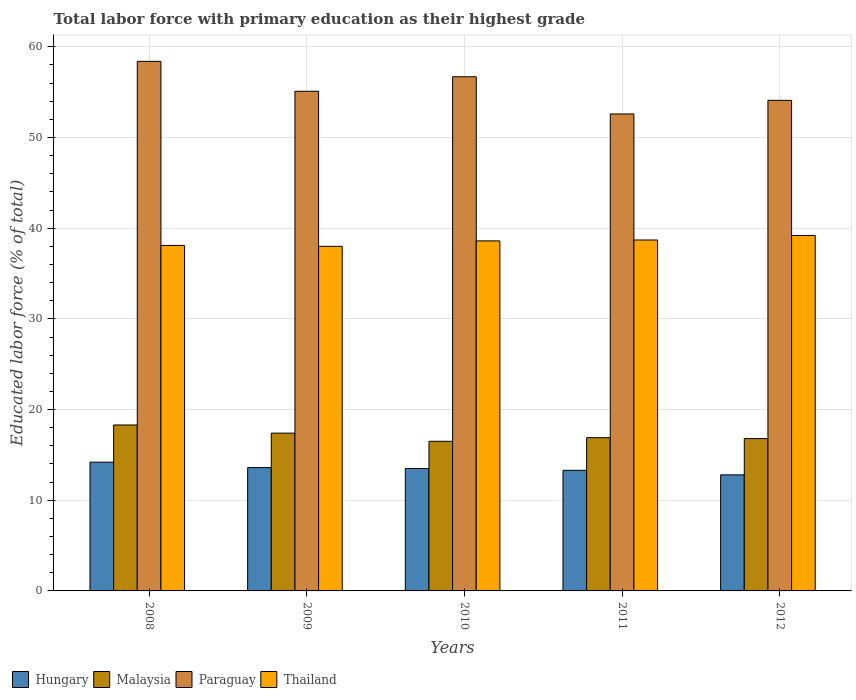How many different coloured bars are there?
Offer a terse response. 4. Are the number of bars per tick equal to the number of legend labels?
Your response must be concise. Yes. Are the number of bars on each tick of the X-axis equal?
Your answer should be very brief. Yes. In how many cases, is the number of bars for a given year not equal to the number of legend labels?
Provide a short and direct response. 0. What is the percentage of total labor force with primary education in Thailand in 2012?
Give a very brief answer. 39.2. Across all years, what is the maximum percentage of total labor force with primary education in Thailand?
Ensure brevity in your answer.  39.2. What is the total percentage of total labor force with primary education in Thailand in the graph?
Provide a succinct answer. 192.6. What is the difference between the percentage of total labor force with primary education in Paraguay in 2008 and that in 2011?
Your answer should be compact. 5.8. What is the difference between the percentage of total labor force with primary education in Malaysia in 2008 and the percentage of total labor force with primary education in Thailand in 2010?
Keep it short and to the point. -20.3. What is the average percentage of total labor force with primary education in Hungary per year?
Your response must be concise. 13.48. In the year 2009, what is the difference between the percentage of total labor force with primary education in Paraguay and percentage of total labor force with primary education in Malaysia?
Ensure brevity in your answer.  37.7. What is the ratio of the percentage of total labor force with primary education in Malaysia in 2009 to that in 2011?
Keep it short and to the point. 1.03. Is the percentage of total labor force with primary education in Paraguay in 2010 less than that in 2011?
Provide a succinct answer. No. Is the difference between the percentage of total labor force with primary education in Paraguay in 2009 and 2012 greater than the difference between the percentage of total labor force with primary education in Malaysia in 2009 and 2012?
Your response must be concise. Yes. What is the difference between the highest and the second highest percentage of total labor force with primary education in Paraguay?
Make the answer very short. 1.7. What is the difference between the highest and the lowest percentage of total labor force with primary education in Paraguay?
Provide a succinct answer. 5.8. What does the 4th bar from the left in 2009 represents?
Ensure brevity in your answer.  Thailand. What does the 1st bar from the right in 2008 represents?
Provide a short and direct response. Thailand. Is it the case that in every year, the sum of the percentage of total labor force with primary education in Paraguay and percentage of total labor force with primary education in Thailand is greater than the percentage of total labor force with primary education in Malaysia?
Offer a terse response. Yes. How many bars are there?
Your answer should be very brief. 20. Are all the bars in the graph horizontal?
Your response must be concise. No. What is the difference between two consecutive major ticks on the Y-axis?
Your answer should be very brief. 10. Are the values on the major ticks of Y-axis written in scientific E-notation?
Give a very brief answer. No. What is the title of the graph?
Your response must be concise. Total labor force with primary education as their highest grade. Does "Iran" appear as one of the legend labels in the graph?
Make the answer very short. No. What is the label or title of the X-axis?
Provide a succinct answer. Years. What is the label or title of the Y-axis?
Provide a short and direct response. Educated labor force (% of total). What is the Educated labor force (% of total) in Hungary in 2008?
Provide a short and direct response. 14.2. What is the Educated labor force (% of total) of Malaysia in 2008?
Your response must be concise. 18.3. What is the Educated labor force (% of total) of Paraguay in 2008?
Your answer should be compact. 58.4. What is the Educated labor force (% of total) of Thailand in 2008?
Offer a terse response. 38.1. What is the Educated labor force (% of total) in Hungary in 2009?
Offer a terse response. 13.6. What is the Educated labor force (% of total) of Malaysia in 2009?
Offer a very short reply. 17.4. What is the Educated labor force (% of total) in Paraguay in 2009?
Your answer should be very brief. 55.1. What is the Educated labor force (% of total) of Hungary in 2010?
Your answer should be very brief. 13.5. What is the Educated labor force (% of total) of Malaysia in 2010?
Your answer should be very brief. 16.5. What is the Educated labor force (% of total) of Paraguay in 2010?
Keep it short and to the point. 56.7. What is the Educated labor force (% of total) in Thailand in 2010?
Your answer should be compact. 38.6. What is the Educated labor force (% of total) of Hungary in 2011?
Provide a short and direct response. 13.3. What is the Educated labor force (% of total) in Malaysia in 2011?
Your response must be concise. 16.9. What is the Educated labor force (% of total) of Paraguay in 2011?
Your answer should be compact. 52.6. What is the Educated labor force (% of total) of Thailand in 2011?
Give a very brief answer. 38.7. What is the Educated labor force (% of total) in Hungary in 2012?
Ensure brevity in your answer.  12.8. What is the Educated labor force (% of total) in Malaysia in 2012?
Provide a succinct answer. 16.8. What is the Educated labor force (% of total) in Paraguay in 2012?
Provide a succinct answer. 54.1. What is the Educated labor force (% of total) of Thailand in 2012?
Ensure brevity in your answer.  39.2. Across all years, what is the maximum Educated labor force (% of total) in Hungary?
Provide a short and direct response. 14.2. Across all years, what is the maximum Educated labor force (% of total) in Malaysia?
Ensure brevity in your answer.  18.3. Across all years, what is the maximum Educated labor force (% of total) of Paraguay?
Provide a short and direct response. 58.4. Across all years, what is the maximum Educated labor force (% of total) in Thailand?
Make the answer very short. 39.2. Across all years, what is the minimum Educated labor force (% of total) in Hungary?
Your response must be concise. 12.8. Across all years, what is the minimum Educated labor force (% of total) of Malaysia?
Make the answer very short. 16.5. Across all years, what is the minimum Educated labor force (% of total) of Paraguay?
Provide a short and direct response. 52.6. What is the total Educated labor force (% of total) of Hungary in the graph?
Provide a short and direct response. 67.4. What is the total Educated labor force (% of total) of Malaysia in the graph?
Your response must be concise. 85.9. What is the total Educated labor force (% of total) in Paraguay in the graph?
Make the answer very short. 276.9. What is the total Educated labor force (% of total) of Thailand in the graph?
Make the answer very short. 192.6. What is the difference between the Educated labor force (% of total) of Hungary in 2008 and that in 2009?
Offer a very short reply. 0.6. What is the difference between the Educated labor force (% of total) of Paraguay in 2008 and that in 2009?
Make the answer very short. 3.3. What is the difference between the Educated labor force (% of total) of Thailand in 2008 and that in 2009?
Provide a succinct answer. 0.1. What is the difference between the Educated labor force (% of total) of Hungary in 2008 and that in 2010?
Ensure brevity in your answer.  0.7. What is the difference between the Educated labor force (% of total) of Malaysia in 2008 and that in 2010?
Ensure brevity in your answer.  1.8. What is the difference between the Educated labor force (% of total) of Paraguay in 2008 and that in 2010?
Your answer should be very brief. 1.7. What is the difference between the Educated labor force (% of total) in Thailand in 2008 and that in 2010?
Your response must be concise. -0.5. What is the difference between the Educated labor force (% of total) in Paraguay in 2008 and that in 2011?
Provide a succinct answer. 5.8. What is the difference between the Educated labor force (% of total) of Thailand in 2008 and that in 2011?
Provide a succinct answer. -0.6. What is the difference between the Educated labor force (% of total) in Hungary in 2008 and that in 2012?
Provide a short and direct response. 1.4. What is the difference between the Educated labor force (% of total) of Paraguay in 2008 and that in 2012?
Ensure brevity in your answer.  4.3. What is the difference between the Educated labor force (% of total) of Thailand in 2008 and that in 2012?
Offer a very short reply. -1.1. What is the difference between the Educated labor force (% of total) in Hungary in 2009 and that in 2010?
Offer a very short reply. 0.1. What is the difference between the Educated labor force (% of total) of Thailand in 2009 and that in 2010?
Your answer should be compact. -0.6. What is the difference between the Educated labor force (% of total) of Hungary in 2009 and that in 2011?
Your answer should be compact. 0.3. What is the difference between the Educated labor force (% of total) of Malaysia in 2009 and that in 2011?
Make the answer very short. 0.5. What is the difference between the Educated labor force (% of total) in Paraguay in 2009 and that in 2011?
Offer a terse response. 2.5. What is the difference between the Educated labor force (% of total) of Thailand in 2009 and that in 2011?
Give a very brief answer. -0.7. What is the difference between the Educated labor force (% of total) in Thailand in 2009 and that in 2012?
Make the answer very short. -1.2. What is the difference between the Educated labor force (% of total) in Paraguay in 2010 and that in 2011?
Provide a succinct answer. 4.1. What is the difference between the Educated labor force (% of total) in Hungary in 2010 and that in 2012?
Provide a short and direct response. 0.7. What is the difference between the Educated labor force (% of total) of Paraguay in 2011 and that in 2012?
Your answer should be compact. -1.5. What is the difference between the Educated labor force (% of total) in Hungary in 2008 and the Educated labor force (% of total) in Malaysia in 2009?
Keep it short and to the point. -3.2. What is the difference between the Educated labor force (% of total) in Hungary in 2008 and the Educated labor force (% of total) in Paraguay in 2009?
Give a very brief answer. -40.9. What is the difference between the Educated labor force (% of total) in Hungary in 2008 and the Educated labor force (% of total) in Thailand in 2009?
Ensure brevity in your answer.  -23.8. What is the difference between the Educated labor force (% of total) in Malaysia in 2008 and the Educated labor force (% of total) in Paraguay in 2009?
Your response must be concise. -36.8. What is the difference between the Educated labor force (% of total) of Malaysia in 2008 and the Educated labor force (% of total) of Thailand in 2009?
Your answer should be compact. -19.7. What is the difference between the Educated labor force (% of total) in Paraguay in 2008 and the Educated labor force (% of total) in Thailand in 2009?
Your answer should be compact. 20.4. What is the difference between the Educated labor force (% of total) of Hungary in 2008 and the Educated labor force (% of total) of Paraguay in 2010?
Give a very brief answer. -42.5. What is the difference between the Educated labor force (% of total) in Hungary in 2008 and the Educated labor force (% of total) in Thailand in 2010?
Offer a very short reply. -24.4. What is the difference between the Educated labor force (% of total) in Malaysia in 2008 and the Educated labor force (% of total) in Paraguay in 2010?
Ensure brevity in your answer.  -38.4. What is the difference between the Educated labor force (% of total) of Malaysia in 2008 and the Educated labor force (% of total) of Thailand in 2010?
Your answer should be compact. -20.3. What is the difference between the Educated labor force (% of total) in Paraguay in 2008 and the Educated labor force (% of total) in Thailand in 2010?
Your answer should be very brief. 19.8. What is the difference between the Educated labor force (% of total) of Hungary in 2008 and the Educated labor force (% of total) of Malaysia in 2011?
Provide a short and direct response. -2.7. What is the difference between the Educated labor force (% of total) in Hungary in 2008 and the Educated labor force (% of total) in Paraguay in 2011?
Provide a succinct answer. -38.4. What is the difference between the Educated labor force (% of total) of Hungary in 2008 and the Educated labor force (% of total) of Thailand in 2011?
Keep it short and to the point. -24.5. What is the difference between the Educated labor force (% of total) in Malaysia in 2008 and the Educated labor force (% of total) in Paraguay in 2011?
Offer a terse response. -34.3. What is the difference between the Educated labor force (% of total) in Malaysia in 2008 and the Educated labor force (% of total) in Thailand in 2011?
Make the answer very short. -20.4. What is the difference between the Educated labor force (% of total) in Hungary in 2008 and the Educated labor force (% of total) in Malaysia in 2012?
Keep it short and to the point. -2.6. What is the difference between the Educated labor force (% of total) of Hungary in 2008 and the Educated labor force (% of total) of Paraguay in 2012?
Provide a short and direct response. -39.9. What is the difference between the Educated labor force (% of total) in Hungary in 2008 and the Educated labor force (% of total) in Thailand in 2012?
Offer a terse response. -25. What is the difference between the Educated labor force (% of total) of Malaysia in 2008 and the Educated labor force (% of total) of Paraguay in 2012?
Give a very brief answer. -35.8. What is the difference between the Educated labor force (% of total) of Malaysia in 2008 and the Educated labor force (% of total) of Thailand in 2012?
Your answer should be compact. -20.9. What is the difference between the Educated labor force (% of total) of Hungary in 2009 and the Educated labor force (% of total) of Malaysia in 2010?
Offer a very short reply. -2.9. What is the difference between the Educated labor force (% of total) in Hungary in 2009 and the Educated labor force (% of total) in Paraguay in 2010?
Ensure brevity in your answer.  -43.1. What is the difference between the Educated labor force (% of total) in Malaysia in 2009 and the Educated labor force (% of total) in Paraguay in 2010?
Offer a terse response. -39.3. What is the difference between the Educated labor force (% of total) of Malaysia in 2009 and the Educated labor force (% of total) of Thailand in 2010?
Make the answer very short. -21.2. What is the difference between the Educated labor force (% of total) in Hungary in 2009 and the Educated labor force (% of total) in Paraguay in 2011?
Offer a terse response. -39. What is the difference between the Educated labor force (% of total) in Hungary in 2009 and the Educated labor force (% of total) in Thailand in 2011?
Your answer should be very brief. -25.1. What is the difference between the Educated labor force (% of total) in Malaysia in 2009 and the Educated labor force (% of total) in Paraguay in 2011?
Give a very brief answer. -35.2. What is the difference between the Educated labor force (% of total) of Malaysia in 2009 and the Educated labor force (% of total) of Thailand in 2011?
Your answer should be compact. -21.3. What is the difference between the Educated labor force (% of total) of Hungary in 2009 and the Educated labor force (% of total) of Paraguay in 2012?
Your answer should be compact. -40.5. What is the difference between the Educated labor force (% of total) of Hungary in 2009 and the Educated labor force (% of total) of Thailand in 2012?
Offer a terse response. -25.6. What is the difference between the Educated labor force (% of total) in Malaysia in 2009 and the Educated labor force (% of total) in Paraguay in 2012?
Your answer should be very brief. -36.7. What is the difference between the Educated labor force (% of total) in Malaysia in 2009 and the Educated labor force (% of total) in Thailand in 2012?
Your answer should be very brief. -21.8. What is the difference between the Educated labor force (% of total) of Paraguay in 2009 and the Educated labor force (% of total) of Thailand in 2012?
Your answer should be compact. 15.9. What is the difference between the Educated labor force (% of total) in Hungary in 2010 and the Educated labor force (% of total) in Paraguay in 2011?
Offer a very short reply. -39.1. What is the difference between the Educated labor force (% of total) of Hungary in 2010 and the Educated labor force (% of total) of Thailand in 2011?
Offer a very short reply. -25.2. What is the difference between the Educated labor force (% of total) in Malaysia in 2010 and the Educated labor force (% of total) in Paraguay in 2011?
Your response must be concise. -36.1. What is the difference between the Educated labor force (% of total) in Malaysia in 2010 and the Educated labor force (% of total) in Thailand in 2011?
Ensure brevity in your answer.  -22.2. What is the difference between the Educated labor force (% of total) of Hungary in 2010 and the Educated labor force (% of total) of Malaysia in 2012?
Your response must be concise. -3.3. What is the difference between the Educated labor force (% of total) of Hungary in 2010 and the Educated labor force (% of total) of Paraguay in 2012?
Give a very brief answer. -40.6. What is the difference between the Educated labor force (% of total) of Hungary in 2010 and the Educated labor force (% of total) of Thailand in 2012?
Your answer should be very brief. -25.7. What is the difference between the Educated labor force (% of total) of Malaysia in 2010 and the Educated labor force (% of total) of Paraguay in 2012?
Offer a very short reply. -37.6. What is the difference between the Educated labor force (% of total) in Malaysia in 2010 and the Educated labor force (% of total) in Thailand in 2012?
Provide a succinct answer. -22.7. What is the difference between the Educated labor force (% of total) of Paraguay in 2010 and the Educated labor force (% of total) of Thailand in 2012?
Offer a terse response. 17.5. What is the difference between the Educated labor force (% of total) in Hungary in 2011 and the Educated labor force (% of total) in Malaysia in 2012?
Provide a succinct answer. -3.5. What is the difference between the Educated labor force (% of total) in Hungary in 2011 and the Educated labor force (% of total) in Paraguay in 2012?
Provide a short and direct response. -40.8. What is the difference between the Educated labor force (% of total) of Hungary in 2011 and the Educated labor force (% of total) of Thailand in 2012?
Offer a very short reply. -25.9. What is the difference between the Educated labor force (% of total) in Malaysia in 2011 and the Educated labor force (% of total) in Paraguay in 2012?
Your response must be concise. -37.2. What is the difference between the Educated labor force (% of total) in Malaysia in 2011 and the Educated labor force (% of total) in Thailand in 2012?
Offer a terse response. -22.3. What is the difference between the Educated labor force (% of total) in Paraguay in 2011 and the Educated labor force (% of total) in Thailand in 2012?
Your answer should be compact. 13.4. What is the average Educated labor force (% of total) of Hungary per year?
Make the answer very short. 13.48. What is the average Educated labor force (% of total) in Malaysia per year?
Offer a terse response. 17.18. What is the average Educated labor force (% of total) of Paraguay per year?
Make the answer very short. 55.38. What is the average Educated labor force (% of total) in Thailand per year?
Ensure brevity in your answer.  38.52. In the year 2008, what is the difference between the Educated labor force (% of total) in Hungary and Educated labor force (% of total) in Malaysia?
Make the answer very short. -4.1. In the year 2008, what is the difference between the Educated labor force (% of total) in Hungary and Educated labor force (% of total) in Paraguay?
Ensure brevity in your answer.  -44.2. In the year 2008, what is the difference between the Educated labor force (% of total) of Hungary and Educated labor force (% of total) of Thailand?
Keep it short and to the point. -23.9. In the year 2008, what is the difference between the Educated labor force (% of total) in Malaysia and Educated labor force (% of total) in Paraguay?
Offer a very short reply. -40.1. In the year 2008, what is the difference between the Educated labor force (% of total) of Malaysia and Educated labor force (% of total) of Thailand?
Your response must be concise. -19.8. In the year 2008, what is the difference between the Educated labor force (% of total) in Paraguay and Educated labor force (% of total) in Thailand?
Offer a terse response. 20.3. In the year 2009, what is the difference between the Educated labor force (% of total) of Hungary and Educated labor force (% of total) of Malaysia?
Keep it short and to the point. -3.8. In the year 2009, what is the difference between the Educated labor force (% of total) of Hungary and Educated labor force (% of total) of Paraguay?
Your response must be concise. -41.5. In the year 2009, what is the difference between the Educated labor force (% of total) in Hungary and Educated labor force (% of total) in Thailand?
Keep it short and to the point. -24.4. In the year 2009, what is the difference between the Educated labor force (% of total) in Malaysia and Educated labor force (% of total) in Paraguay?
Offer a terse response. -37.7. In the year 2009, what is the difference between the Educated labor force (% of total) in Malaysia and Educated labor force (% of total) in Thailand?
Provide a short and direct response. -20.6. In the year 2010, what is the difference between the Educated labor force (% of total) of Hungary and Educated labor force (% of total) of Malaysia?
Offer a terse response. -3. In the year 2010, what is the difference between the Educated labor force (% of total) of Hungary and Educated labor force (% of total) of Paraguay?
Your answer should be very brief. -43.2. In the year 2010, what is the difference between the Educated labor force (% of total) of Hungary and Educated labor force (% of total) of Thailand?
Your answer should be compact. -25.1. In the year 2010, what is the difference between the Educated labor force (% of total) in Malaysia and Educated labor force (% of total) in Paraguay?
Your answer should be compact. -40.2. In the year 2010, what is the difference between the Educated labor force (% of total) in Malaysia and Educated labor force (% of total) in Thailand?
Your response must be concise. -22.1. In the year 2011, what is the difference between the Educated labor force (% of total) in Hungary and Educated labor force (% of total) in Malaysia?
Your answer should be compact. -3.6. In the year 2011, what is the difference between the Educated labor force (% of total) of Hungary and Educated labor force (% of total) of Paraguay?
Offer a terse response. -39.3. In the year 2011, what is the difference between the Educated labor force (% of total) in Hungary and Educated labor force (% of total) in Thailand?
Your answer should be very brief. -25.4. In the year 2011, what is the difference between the Educated labor force (% of total) in Malaysia and Educated labor force (% of total) in Paraguay?
Your response must be concise. -35.7. In the year 2011, what is the difference between the Educated labor force (% of total) of Malaysia and Educated labor force (% of total) of Thailand?
Your answer should be compact. -21.8. In the year 2011, what is the difference between the Educated labor force (% of total) in Paraguay and Educated labor force (% of total) in Thailand?
Ensure brevity in your answer.  13.9. In the year 2012, what is the difference between the Educated labor force (% of total) in Hungary and Educated labor force (% of total) in Malaysia?
Offer a very short reply. -4. In the year 2012, what is the difference between the Educated labor force (% of total) of Hungary and Educated labor force (% of total) of Paraguay?
Offer a very short reply. -41.3. In the year 2012, what is the difference between the Educated labor force (% of total) of Hungary and Educated labor force (% of total) of Thailand?
Ensure brevity in your answer.  -26.4. In the year 2012, what is the difference between the Educated labor force (% of total) in Malaysia and Educated labor force (% of total) in Paraguay?
Your answer should be compact. -37.3. In the year 2012, what is the difference between the Educated labor force (% of total) in Malaysia and Educated labor force (% of total) in Thailand?
Give a very brief answer. -22.4. What is the ratio of the Educated labor force (% of total) in Hungary in 2008 to that in 2009?
Your answer should be compact. 1.04. What is the ratio of the Educated labor force (% of total) of Malaysia in 2008 to that in 2009?
Make the answer very short. 1.05. What is the ratio of the Educated labor force (% of total) in Paraguay in 2008 to that in 2009?
Your answer should be compact. 1.06. What is the ratio of the Educated labor force (% of total) of Hungary in 2008 to that in 2010?
Provide a short and direct response. 1.05. What is the ratio of the Educated labor force (% of total) in Malaysia in 2008 to that in 2010?
Make the answer very short. 1.11. What is the ratio of the Educated labor force (% of total) in Paraguay in 2008 to that in 2010?
Your answer should be compact. 1.03. What is the ratio of the Educated labor force (% of total) of Thailand in 2008 to that in 2010?
Your answer should be very brief. 0.99. What is the ratio of the Educated labor force (% of total) in Hungary in 2008 to that in 2011?
Offer a terse response. 1.07. What is the ratio of the Educated labor force (% of total) of Malaysia in 2008 to that in 2011?
Give a very brief answer. 1.08. What is the ratio of the Educated labor force (% of total) of Paraguay in 2008 to that in 2011?
Make the answer very short. 1.11. What is the ratio of the Educated labor force (% of total) of Thailand in 2008 to that in 2011?
Your response must be concise. 0.98. What is the ratio of the Educated labor force (% of total) of Hungary in 2008 to that in 2012?
Offer a very short reply. 1.11. What is the ratio of the Educated labor force (% of total) in Malaysia in 2008 to that in 2012?
Make the answer very short. 1.09. What is the ratio of the Educated labor force (% of total) in Paraguay in 2008 to that in 2012?
Give a very brief answer. 1.08. What is the ratio of the Educated labor force (% of total) of Thailand in 2008 to that in 2012?
Give a very brief answer. 0.97. What is the ratio of the Educated labor force (% of total) in Hungary in 2009 to that in 2010?
Keep it short and to the point. 1.01. What is the ratio of the Educated labor force (% of total) in Malaysia in 2009 to that in 2010?
Make the answer very short. 1.05. What is the ratio of the Educated labor force (% of total) of Paraguay in 2009 to that in 2010?
Make the answer very short. 0.97. What is the ratio of the Educated labor force (% of total) in Thailand in 2009 to that in 2010?
Offer a terse response. 0.98. What is the ratio of the Educated labor force (% of total) in Hungary in 2009 to that in 2011?
Offer a very short reply. 1.02. What is the ratio of the Educated labor force (% of total) of Malaysia in 2009 to that in 2011?
Provide a short and direct response. 1.03. What is the ratio of the Educated labor force (% of total) in Paraguay in 2009 to that in 2011?
Provide a succinct answer. 1.05. What is the ratio of the Educated labor force (% of total) in Thailand in 2009 to that in 2011?
Make the answer very short. 0.98. What is the ratio of the Educated labor force (% of total) in Malaysia in 2009 to that in 2012?
Your answer should be very brief. 1.04. What is the ratio of the Educated labor force (% of total) in Paraguay in 2009 to that in 2012?
Your response must be concise. 1.02. What is the ratio of the Educated labor force (% of total) of Thailand in 2009 to that in 2012?
Your answer should be very brief. 0.97. What is the ratio of the Educated labor force (% of total) of Hungary in 2010 to that in 2011?
Keep it short and to the point. 1.01. What is the ratio of the Educated labor force (% of total) of Malaysia in 2010 to that in 2011?
Keep it short and to the point. 0.98. What is the ratio of the Educated labor force (% of total) in Paraguay in 2010 to that in 2011?
Offer a very short reply. 1.08. What is the ratio of the Educated labor force (% of total) in Thailand in 2010 to that in 2011?
Keep it short and to the point. 1. What is the ratio of the Educated labor force (% of total) in Hungary in 2010 to that in 2012?
Provide a short and direct response. 1.05. What is the ratio of the Educated labor force (% of total) of Malaysia in 2010 to that in 2012?
Provide a succinct answer. 0.98. What is the ratio of the Educated labor force (% of total) of Paraguay in 2010 to that in 2012?
Offer a terse response. 1.05. What is the ratio of the Educated labor force (% of total) of Thailand in 2010 to that in 2012?
Provide a succinct answer. 0.98. What is the ratio of the Educated labor force (% of total) of Hungary in 2011 to that in 2012?
Your answer should be very brief. 1.04. What is the ratio of the Educated labor force (% of total) of Paraguay in 2011 to that in 2012?
Give a very brief answer. 0.97. What is the ratio of the Educated labor force (% of total) of Thailand in 2011 to that in 2012?
Provide a succinct answer. 0.99. What is the difference between the highest and the second highest Educated labor force (% of total) in Hungary?
Your answer should be very brief. 0.6. What is the difference between the highest and the second highest Educated labor force (% of total) of Thailand?
Make the answer very short. 0.5. What is the difference between the highest and the lowest Educated labor force (% of total) in Malaysia?
Your response must be concise. 1.8. What is the difference between the highest and the lowest Educated labor force (% of total) of Paraguay?
Provide a succinct answer. 5.8. 